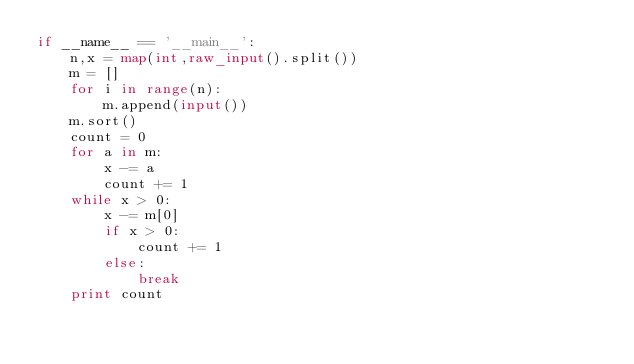Convert code to text. <code><loc_0><loc_0><loc_500><loc_500><_Python_>if __name__ == '__main__':
    n,x = map(int,raw_input().split())
    m = []
    for i in range(n):
        m.append(input())
    m.sort()
    count = 0
    for a in m:
        x -= a
        count += 1
    while x > 0:
        x -= m[0]
        if x > 0:
            count += 1
        else:
            break
    print count
</code> 